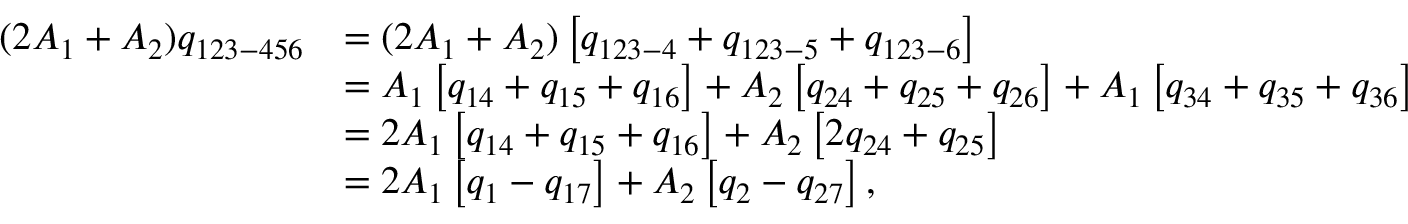Convert formula to latex. <formula><loc_0><loc_0><loc_500><loc_500>\begin{array} { r l } { ( 2 A _ { 1 } + A _ { 2 } ) q _ { 1 2 3 - 4 5 6 } } & { = ( 2 A _ { 1 } + A _ { 2 } ) \left [ q _ { 1 2 3 - 4 } + q _ { 1 2 3 - 5 } + q _ { 1 2 3 - 6 } \right ] } \\ & { = A _ { 1 } \left [ q _ { 1 4 } + q _ { 1 5 } + q _ { 1 6 } \right ] + A _ { 2 } \left [ q _ { 2 4 } + q _ { 2 5 } + q _ { 2 6 } \right ] + A _ { 1 } \left [ q _ { 3 4 } + q _ { 3 5 } + q _ { 3 6 } \right ] } \\ & { = 2 A _ { 1 } \left [ q _ { 1 4 } + q _ { 1 5 } + q _ { 1 6 } \right ] + A _ { 2 } \left [ 2 q _ { 2 4 } + q _ { 2 5 } \right ] } \\ & { = 2 A _ { 1 } \left [ q _ { 1 } - q _ { 1 7 } \right ] + A _ { 2 } \left [ q _ { 2 } - q _ { 2 7 } \right ] { , } } \end{array}</formula> 